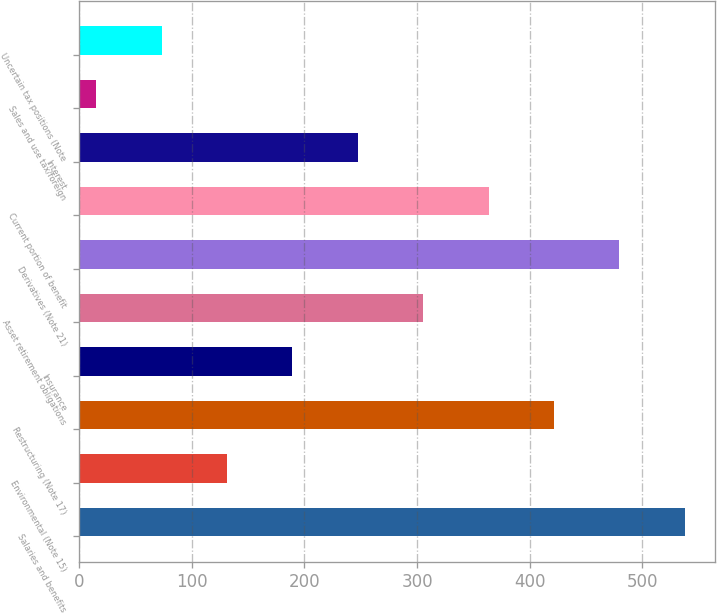<chart> <loc_0><loc_0><loc_500><loc_500><bar_chart><fcel>Salaries and benefits<fcel>Environmental (Note 15)<fcel>Restructuring (Note 17)<fcel>Insurance<fcel>Asset retirement obligations<fcel>Derivatives (Note 21)<fcel>Current portion of benefit<fcel>Interest<fcel>Sales and use tax/foreign<fcel>Uncertain tax positions (Note<nl><fcel>537.9<fcel>131.2<fcel>421.7<fcel>189.3<fcel>305.5<fcel>479.8<fcel>363.6<fcel>247.4<fcel>15<fcel>73.1<nl></chart> 